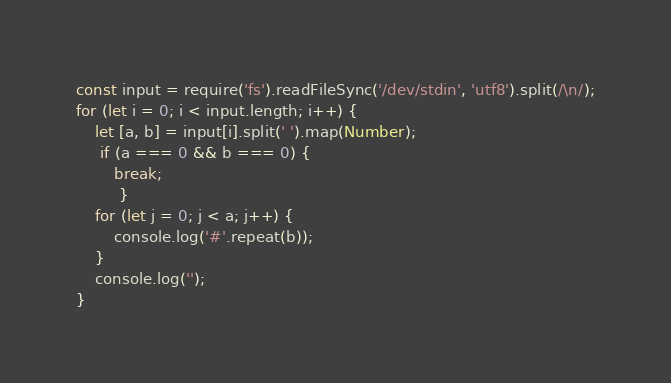Convert code to text. <code><loc_0><loc_0><loc_500><loc_500><_JavaScript_>const input = require('fs').readFileSync('/dev/stdin', 'utf8').split(/\n/);
for (let i = 0; i < input.length; i++) {
    let [a, b] = input[i].split(' ').map(Number);
     if (a === 0 && b === 0) {
        break;
         }
    for (let j = 0; j < a; j++) {
        console.log('#'.repeat(b));
    }
    console.log('');
}

</code> 